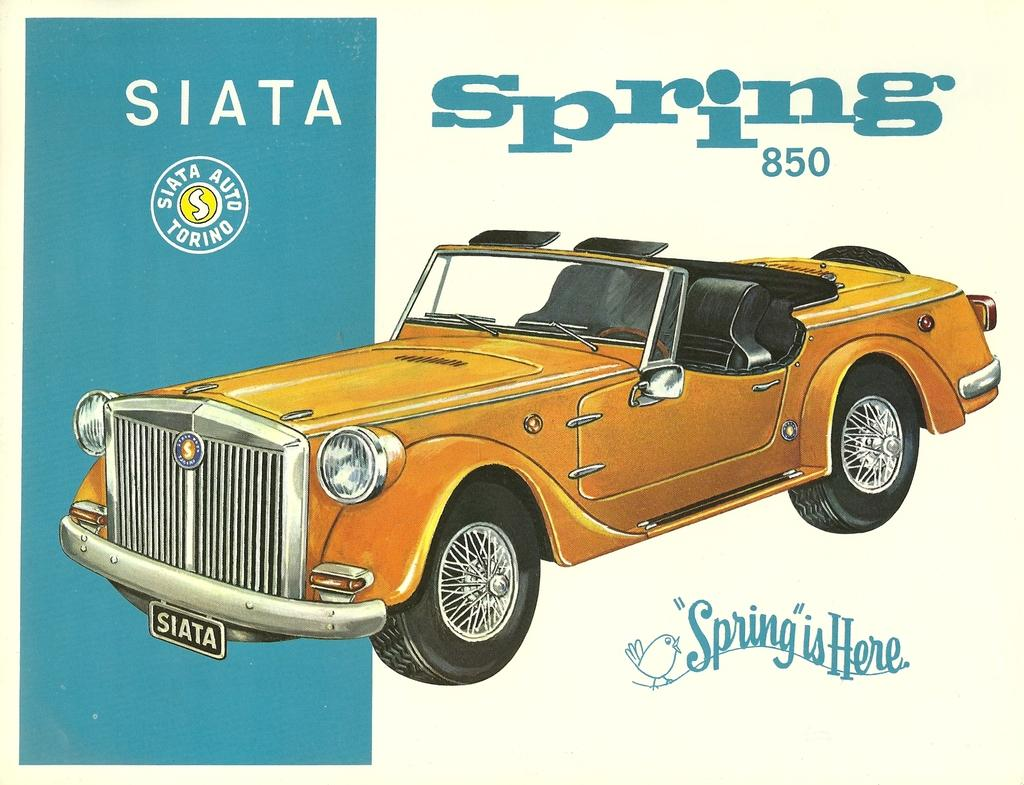What can be seen on the poster in the image? The facts provided do not specify what is on the poster, so we cannot answer this question definitively. What type of vehicle is present in the image? There is a yellow color car in the image. What else is included in the image besides the car? There is some text and a logo in the image. Can you see a bee flying near the car in the image? There is no bee present in the image. Is there a hill visible in the background of the image? The facts provided do not mention any hills or background elements, so we cannot answer this question definitively. 